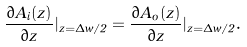Convert formula to latex. <formula><loc_0><loc_0><loc_500><loc_500>\frac { \partial A _ { i } ( z ) } { \partial z } | _ { z = \Delta w / 2 } = \frac { \partial A _ { o } ( z ) } { \partial z } | _ { z = \Delta w / 2 } .</formula> 